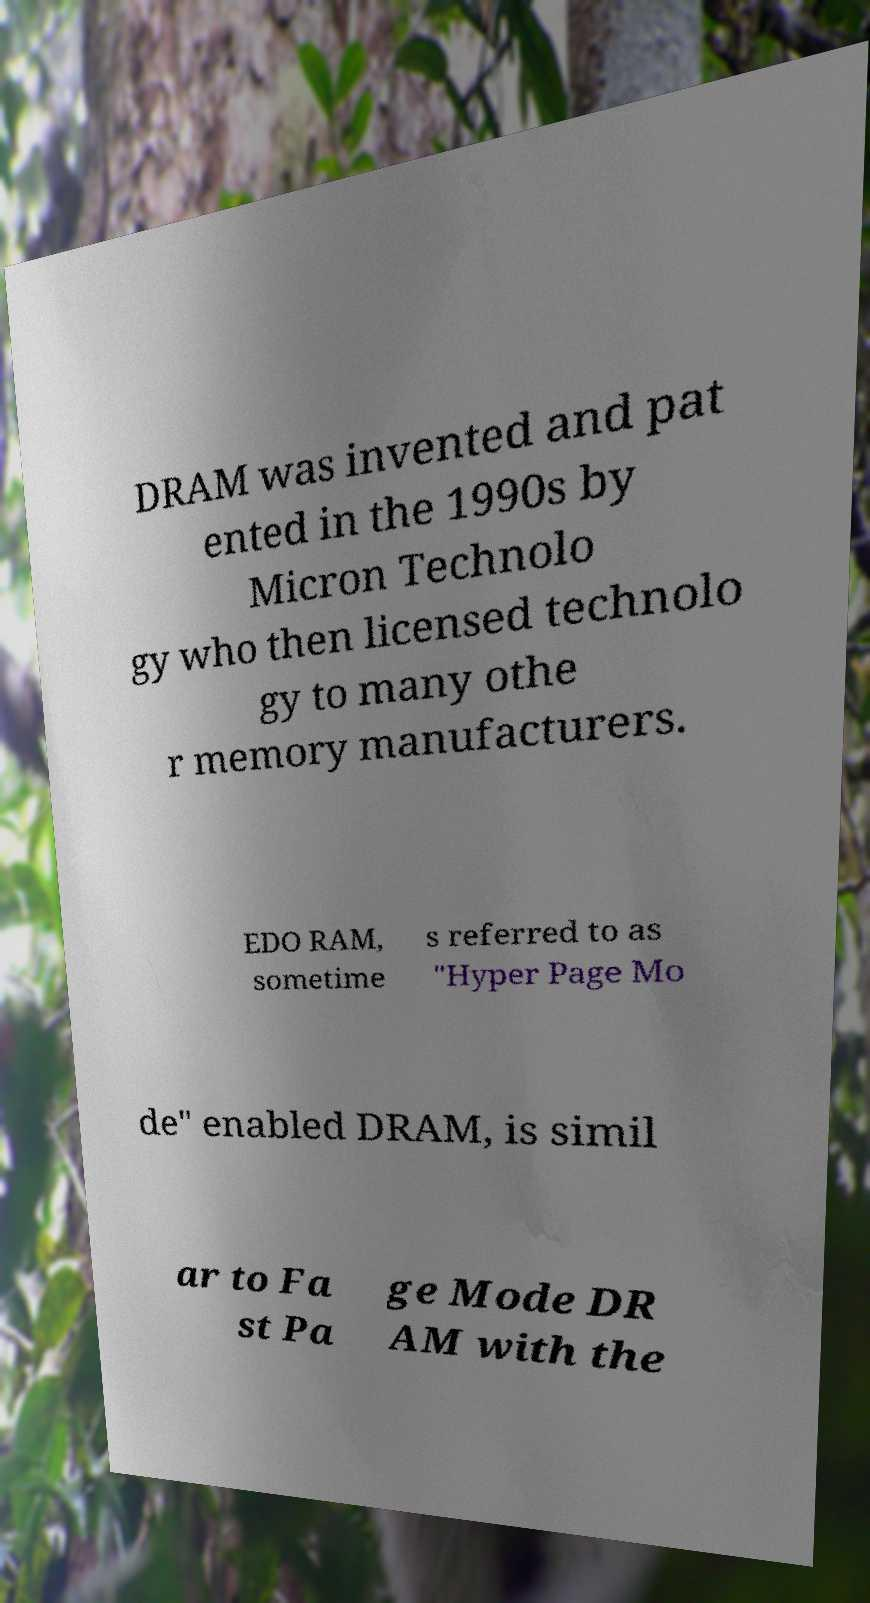I need the written content from this picture converted into text. Can you do that? DRAM was invented and pat ented in the 1990s by Micron Technolo gy who then licensed technolo gy to many othe r memory manufacturers. EDO RAM, sometime s referred to as "Hyper Page Mo de" enabled DRAM, is simil ar to Fa st Pa ge Mode DR AM with the 